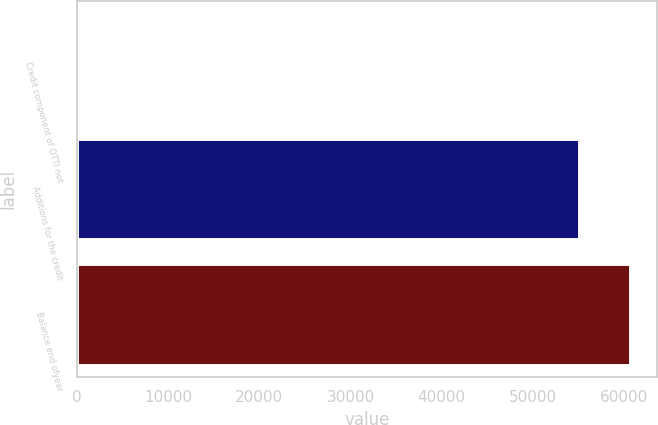Convert chart to OTSL. <chart><loc_0><loc_0><loc_500><loc_500><bar_chart><fcel>Credit component of OTTI not<fcel>Additions for the credit<fcel>Balance end ofyear<nl><fcel>24<fcel>55127<fcel>60639.7<nl></chart> 